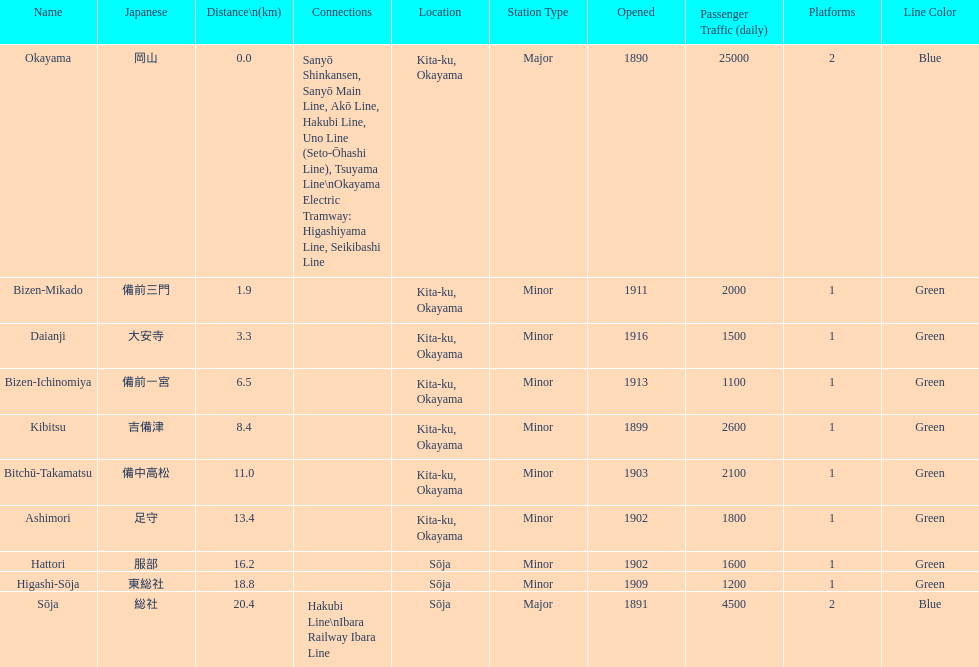Name only the stations that have connections to other lines. Okayama, Sōja. 